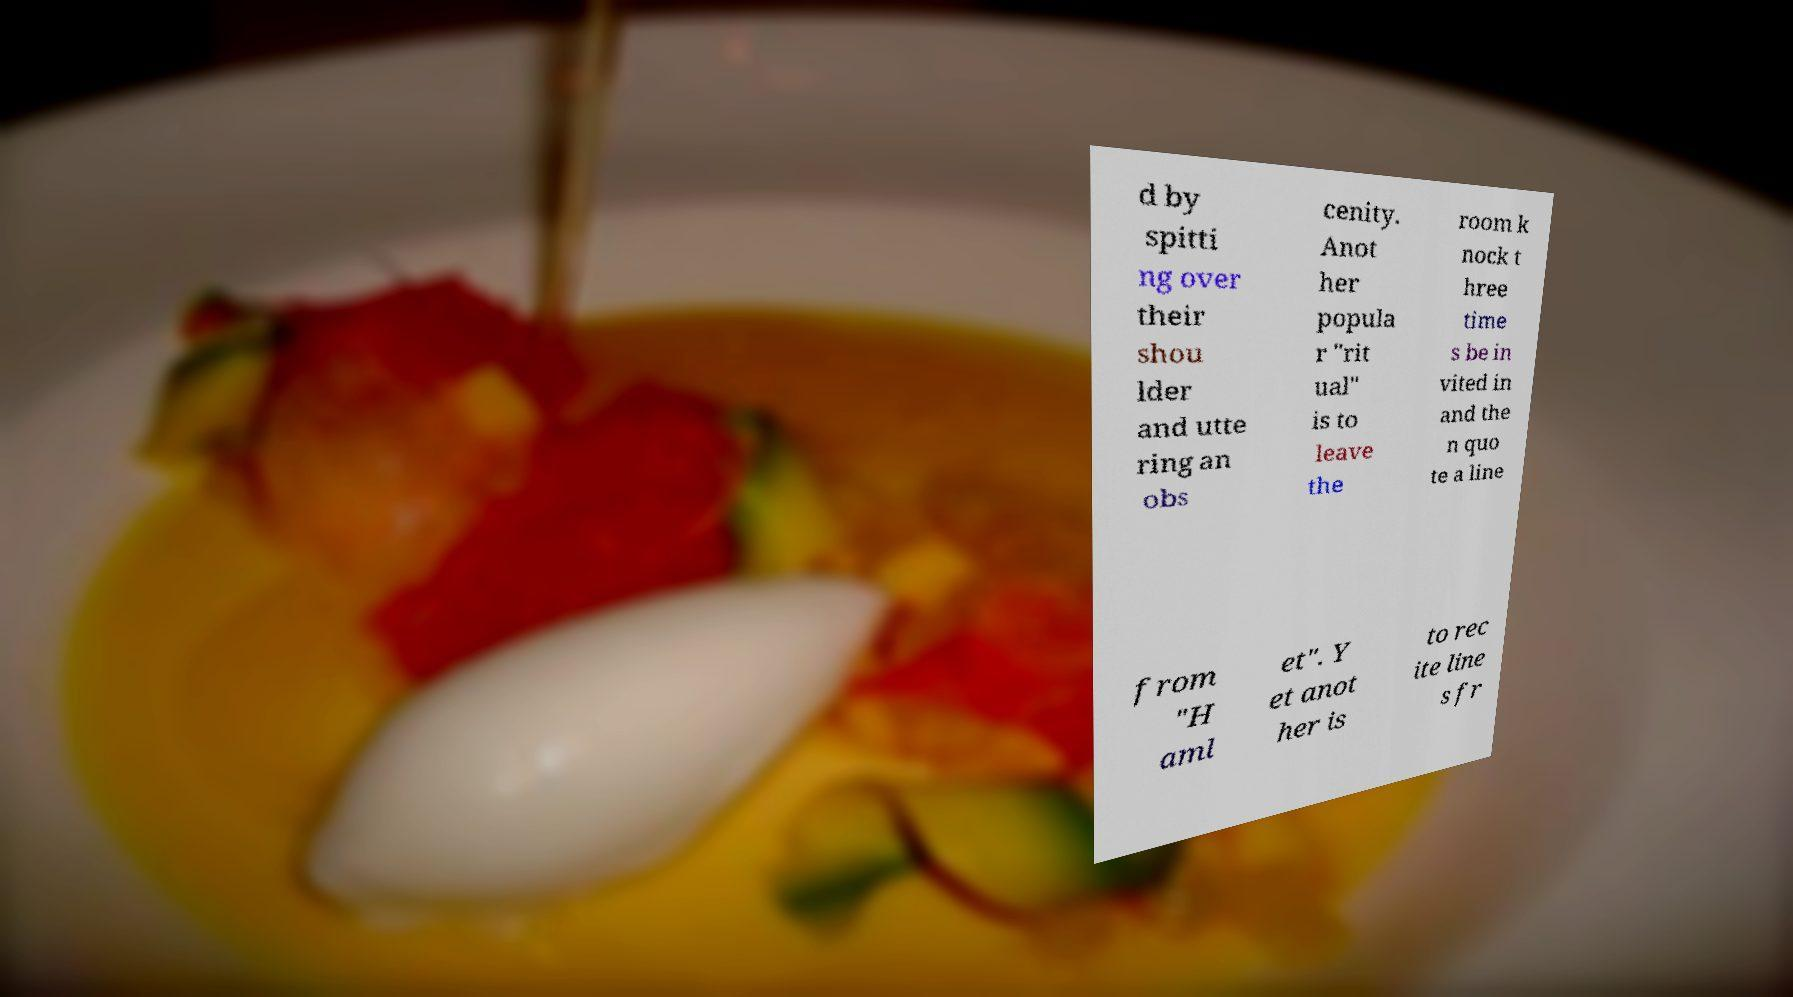There's text embedded in this image that I need extracted. Can you transcribe it verbatim? d by spitti ng over their shou lder and utte ring an obs cenity. Anot her popula r "rit ual" is to leave the room k nock t hree time s be in vited in and the n quo te a line from "H aml et". Y et anot her is to rec ite line s fr 